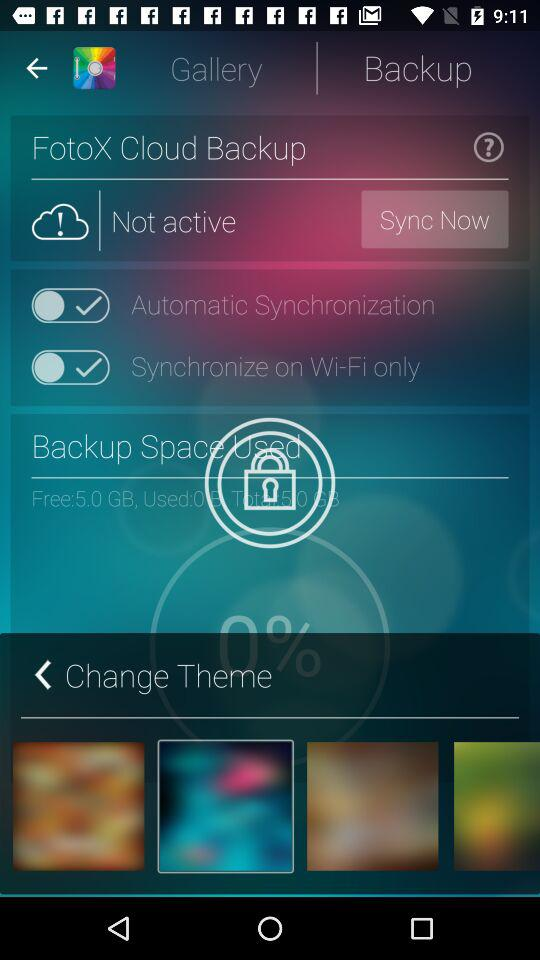How much free space is there on the device?
Answer the question using a single word or phrase. 5.0 GB 